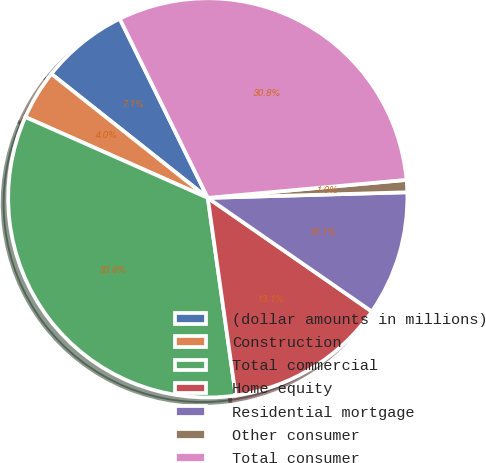<chart> <loc_0><loc_0><loc_500><loc_500><pie_chart><fcel>(dollar amounts in millions)<fcel>Construction<fcel>Total commercial<fcel>Home equity<fcel>Residential mortgage<fcel>Other consumer<fcel>Total consumer<nl><fcel>7.06%<fcel>4.03%<fcel>33.87%<fcel>13.12%<fcel>10.09%<fcel>0.99%<fcel>30.83%<nl></chart> 